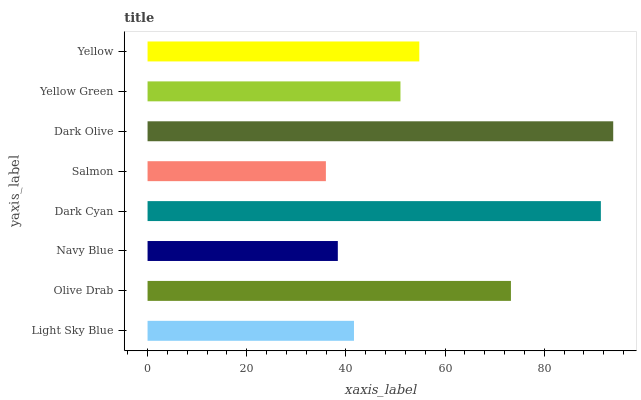Is Salmon the minimum?
Answer yes or no. Yes. Is Dark Olive the maximum?
Answer yes or no. Yes. Is Olive Drab the minimum?
Answer yes or no. No. Is Olive Drab the maximum?
Answer yes or no. No. Is Olive Drab greater than Light Sky Blue?
Answer yes or no. Yes. Is Light Sky Blue less than Olive Drab?
Answer yes or no. Yes. Is Light Sky Blue greater than Olive Drab?
Answer yes or no. No. Is Olive Drab less than Light Sky Blue?
Answer yes or no. No. Is Yellow the high median?
Answer yes or no. Yes. Is Yellow Green the low median?
Answer yes or no. Yes. Is Olive Drab the high median?
Answer yes or no. No. Is Yellow the low median?
Answer yes or no. No. 